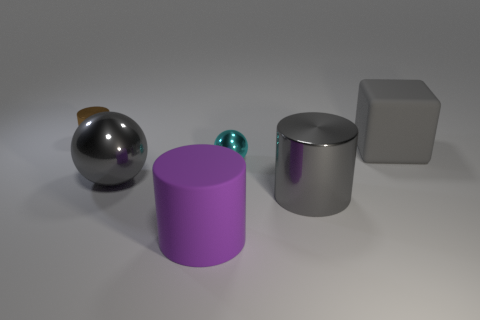Subtract all brown cylinders. How many cylinders are left? 2 Subtract all gray cylinders. How many cylinders are left? 2 Subtract all spheres. How many objects are left? 4 Add 3 tiny cyan metal objects. How many objects exist? 9 Add 5 brown cylinders. How many brown cylinders exist? 6 Subtract 0 brown balls. How many objects are left? 6 Subtract 1 cylinders. How many cylinders are left? 2 Subtract all purple blocks. Subtract all yellow cylinders. How many blocks are left? 1 Subtract all blue cubes. How many cyan spheres are left? 1 Subtract all large green shiny things. Subtract all large gray metallic spheres. How many objects are left? 5 